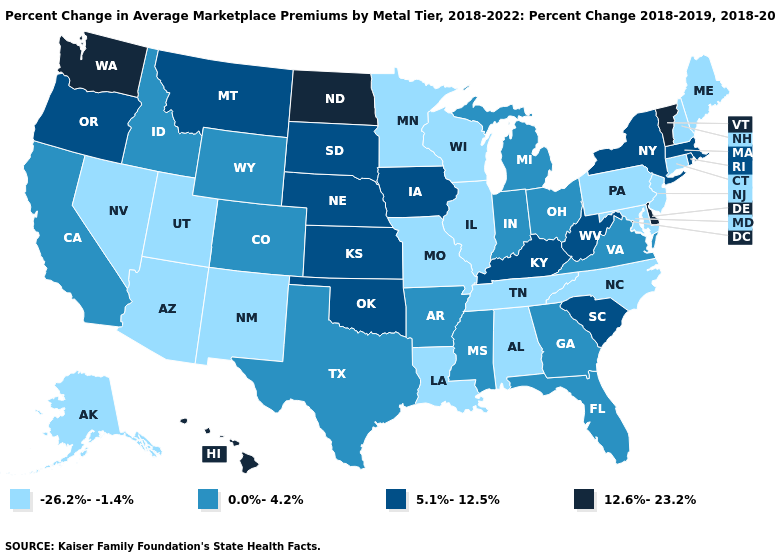Name the states that have a value in the range 5.1%-12.5%?
Short answer required. Iowa, Kansas, Kentucky, Massachusetts, Montana, Nebraska, New York, Oklahoma, Oregon, Rhode Island, South Carolina, South Dakota, West Virginia. Name the states that have a value in the range 0.0%-4.2%?
Be succinct. Arkansas, California, Colorado, Florida, Georgia, Idaho, Indiana, Michigan, Mississippi, Ohio, Texas, Virginia, Wyoming. Among the states that border Nebraska , which have the highest value?
Short answer required. Iowa, Kansas, South Dakota. Which states have the highest value in the USA?
Write a very short answer. Delaware, Hawaii, North Dakota, Vermont, Washington. What is the value of Connecticut?
Be succinct. -26.2%--1.4%. Which states have the lowest value in the USA?
Quick response, please. Alabama, Alaska, Arizona, Connecticut, Illinois, Louisiana, Maine, Maryland, Minnesota, Missouri, Nevada, New Hampshire, New Jersey, New Mexico, North Carolina, Pennsylvania, Tennessee, Utah, Wisconsin. What is the highest value in states that border Florida?
Concise answer only. 0.0%-4.2%. What is the value of Arizona?
Quick response, please. -26.2%--1.4%. Which states hav the highest value in the West?
Write a very short answer. Hawaii, Washington. What is the value of Tennessee?
Concise answer only. -26.2%--1.4%. What is the value of Utah?
Write a very short answer. -26.2%--1.4%. Among the states that border Oklahoma , which have the lowest value?
Concise answer only. Missouri, New Mexico. What is the value of Illinois?
Quick response, please. -26.2%--1.4%. Name the states that have a value in the range 12.6%-23.2%?
Concise answer only. Delaware, Hawaii, North Dakota, Vermont, Washington. Is the legend a continuous bar?
Answer briefly. No. 